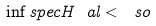<formula> <loc_0><loc_0><loc_500><loc_500>\inf s p e c H _ { \ } a l < \ s o</formula> 